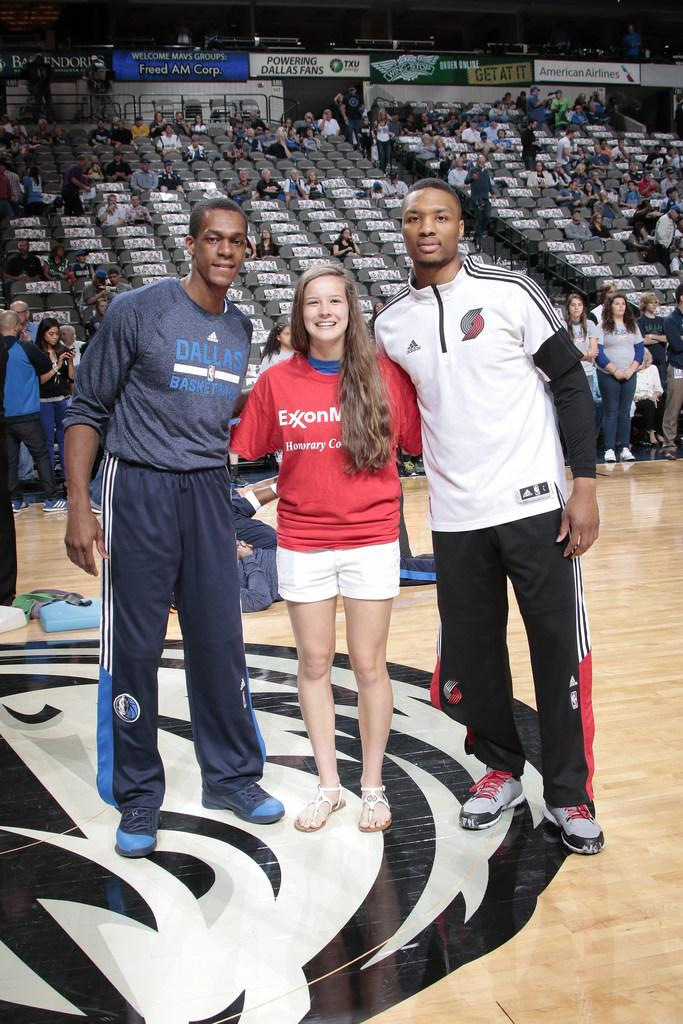Provide a one-sentence caption for the provided image. A tall man with a Dallas basketball shirt poses for a photo with two other people. 